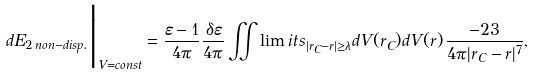<formula> <loc_0><loc_0><loc_500><loc_500>d E _ { 2 \, n o n - d i s p . } \Big | _ { V = c o n s t } = \frac { \varepsilon - 1 } { 4 \pi } \frac { \delta \varepsilon } { 4 \pi } \iint \lim i t s _ { | { r } _ { C } - { r } | \geq \lambda } d V ( { r } _ { C } ) d V ( { r } ) \, \frac { - 2 3 } { 4 \pi | { r } _ { C } - { r } | ^ { 7 } } ,</formula> 